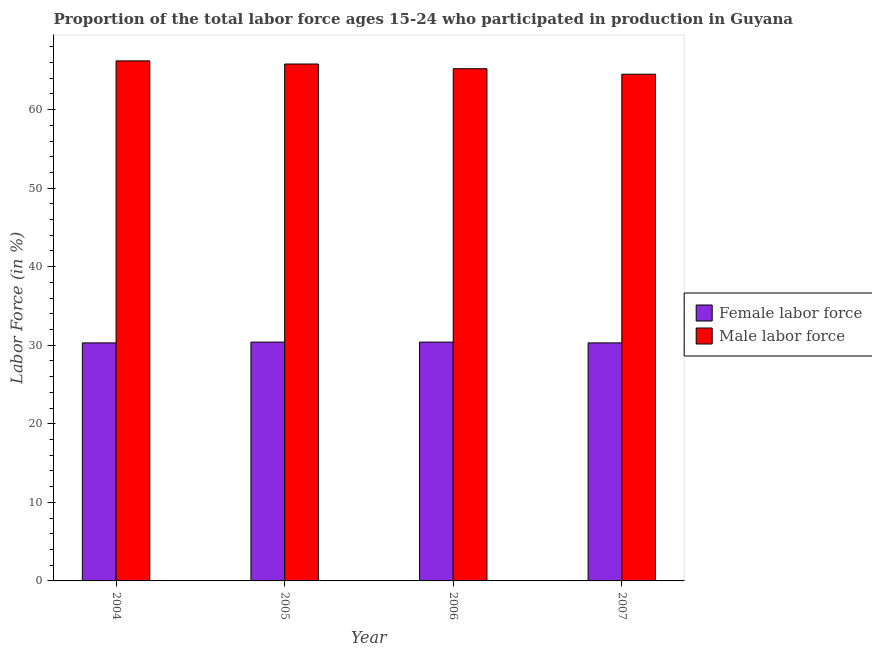How many groups of bars are there?
Your answer should be very brief. 4. Are the number of bars on each tick of the X-axis equal?
Your answer should be very brief. Yes. How many bars are there on the 1st tick from the left?
Offer a very short reply. 2. How many bars are there on the 2nd tick from the right?
Your answer should be compact. 2. In how many cases, is the number of bars for a given year not equal to the number of legend labels?
Ensure brevity in your answer.  0. What is the percentage of female labor force in 2007?
Give a very brief answer. 30.3. Across all years, what is the maximum percentage of male labour force?
Provide a short and direct response. 66.2. Across all years, what is the minimum percentage of female labor force?
Provide a succinct answer. 30.3. What is the total percentage of female labor force in the graph?
Offer a very short reply. 121.4. What is the difference between the percentage of female labor force in 2006 and that in 2007?
Give a very brief answer. 0.1. What is the difference between the percentage of male labour force in 2004 and the percentage of female labor force in 2007?
Make the answer very short. 1.7. What is the average percentage of female labor force per year?
Keep it short and to the point. 30.35. In how many years, is the percentage of female labor force greater than 50 %?
Ensure brevity in your answer.  0. What is the ratio of the percentage of female labor force in 2005 to that in 2007?
Keep it short and to the point. 1. What is the difference between the highest and the second highest percentage of male labour force?
Your answer should be compact. 0.4. What is the difference between the highest and the lowest percentage of female labor force?
Your answer should be very brief. 0.1. Is the sum of the percentage of female labor force in 2004 and 2007 greater than the maximum percentage of male labour force across all years?
Provide a succinct answer. Yes. What does the 1st bar from the left in 2004 represents?
Offer a very short reply. Female labor force. What does the 2nd bar from the right in 2006 represents?
Your answer should be very brief. Female labor force. How many bars are there?
Make the answer very short. 8. How many years are there in the graph?
Keep it short and to the point. 4. What is the difference between two consecutive major ticks on the Y-axis?
Your answer should be very brief. 10. Are the values on the major ticks of Y-axis written in scientific E-notation?
Keep it short and to the point. No. Does the graph contain any zero values?
Your answer should be compact. No. Where does the legend appear in the graph?
Provide a succinct answer. Center right. How many legend labels are there?
Your answer should be very brief. 2. How are the legend labels stacked?
Your response must be concise. Vertical. What is the title of the graph?
Provide a short and direct response. Proportion of the total labor force ages 15-24 who participated in production in Guyana. What is the Labor Force (in %) in Female labor force in 2004?
Keep it short and to the point. 30.3. What is the Labor Force (in %) in Male labor force in 2004?
Your response must be concise. 66.2. What is the Labor Force (in %) in Female labor force in 2005?
Your response must be concise. 30.4. What is the Labor Force (in %) of Male labor force in 2005?
Ensure brevity in your answer.  65.8. What is the Labor Force (in %) of Female labor force in 2006?
Provide a succinct answer. 30.4. What is the Labor Force (in %) in Male labor force in 2006?
Keep it short and to the point. 65.2. What is the Labor Force (in %) in Female labor force in 2007?
Ensure brevity in your answer.  30.3. What is the Labor Force (in %) of Male labor force in 2007?
Keep it short and to the point. 64.5. Across all years, what is the maximum Labor Force (in %) of Female labor force?
Keep it short and to the point. 30.4. Across all years, what is the maximum Labor Force (in %) in Male labor force?
Your answer should be compact. 66.2. Across all years, what is the minimum Labor Force (in %) of Female labor force?
Provide a short and direct response. 30.3. Across all years, what is the minimum Labor Force (in %) of Male labor force?
Offer a terse response. 64.5. What is the total Labor Force (in %) of Female labor force in the graph?
Offer a terse response. 121.4. What is the total Labor Force (in %) in Male labor force in the graph?
Provide a succinct answer. 261.7. What is the difference between the Labor Force (in %) of Female labor force in 2004 and that in 2007?
Provide a succinct answer. 0. What is the difference between the Labor Force (in %) of Male labor force in 2004 and that in 2007?
Ensure brevity in your answer.  1.7. What is the difference between the Labor Force (in %) of Male labor force in 2005 and that in 2007?
Your answer should be very brief. 1.3. What is the difference between the Labor Force (in %) of Male labor force in 2006 and that in 2007?
Provide a succinct answer. 0.7. What is the difference between the Labor Force (in %) of Female labor force in 2004 and the Labor Force (in %) of Male labor force in 2005?
Ensure brevity in your answer.  -35.5. What is the difference between the Labor Force (in %) of Female labor force in 2004 and the Labor Force (in %) of Male labor force in 2006?
Your answer should be compact. -34.9. What is the difference between the Labor Force (in %) of Female labor force in 2004 and the Labor Force (in %) of Male labor force in 2007?
Offer a very short reply. -34.2. What is the difference between the Labor Force (in %) in Female labor force in 2005 and the Labor Force (in %) in Male labor force in 2006?
Offer a terse response. -34.8. What is the difference between the Labor Force (in %) of Female labor force in 2005 and the Labor Force (in %) of Male labor force in 2007?
Your response must be concise. -34.1. What is the difference between the Labor Force (in %) in Female labor force in 2006 and the Labor Force (in %) in Male labor force in 2007?
Ensure brevity in your answer.  -34.1. What is the average Labor Force (in %) of Female labor force per year?
Provide a short and direct response. 30.35. What is the average Labor Force (in %) in Male labor force per year?
Provide a succinct answer. 65.42. In the year 2004, what is the difference between the Labor Force (in %) in Female labor force and Labor Force (in %) in Male labor force?
Ensure brevity in your answer.  -35.9. In the year 2005, what is the difference between the Labor Force (in %) of Female labor force and Labor Force (in %) of Male labor force?
Keep it short and to the point. -35.4. In the year 2006, what is the difference between the Labor Force (in %) of Female labor force and Labor Force (in %) of Male labor force?
Offer a very short reply. -34.8. In the year 2007, what is the difference between the Labor Force (in %) in Female labor force and Labor Force (in %) in Male labor force?
Your answer should be compact. -34.2. What is the ratio of the Labor Force (in %) of Female labor force in 2004 to that in 2005?
Provide a succinct answer. 1. What is the ratio of the Labor Force (in %) of Male labor force in 2004 to that in 2006?
Offer a terse response. 1.02. What is the ratio of the Labor Force (in %) of Male labor force in 2004 to that in 2007?
Your response must be concise. 1.03. What is the ratio of the Labor Force (in %) in Female labor force in 2005 to that in 2006?
Make the answer very short. 1. What is the ratio of the Labor Force (in %) in Male labor force in 2005 to that in 2006?
Keep it short and to the point. 1.01. What is the ratio of the Labor Force (in %) of Male labor force in 2005 to that in 2007?
Offer a terse response. 1.02. What is the ratio of the Labor Force (in %) in Female labor force in 2006 to that in 2007?
Give a very brief answer. 1. What is the ratio of the Labor Force (in %) of Male labor force in 2006 to that in 2007?
Your answer should be compact. 1.01. What is the difference between the highest and the second highest Labor Force (in %) in Male labor force?
Provide a short and direct response. 0.4. 